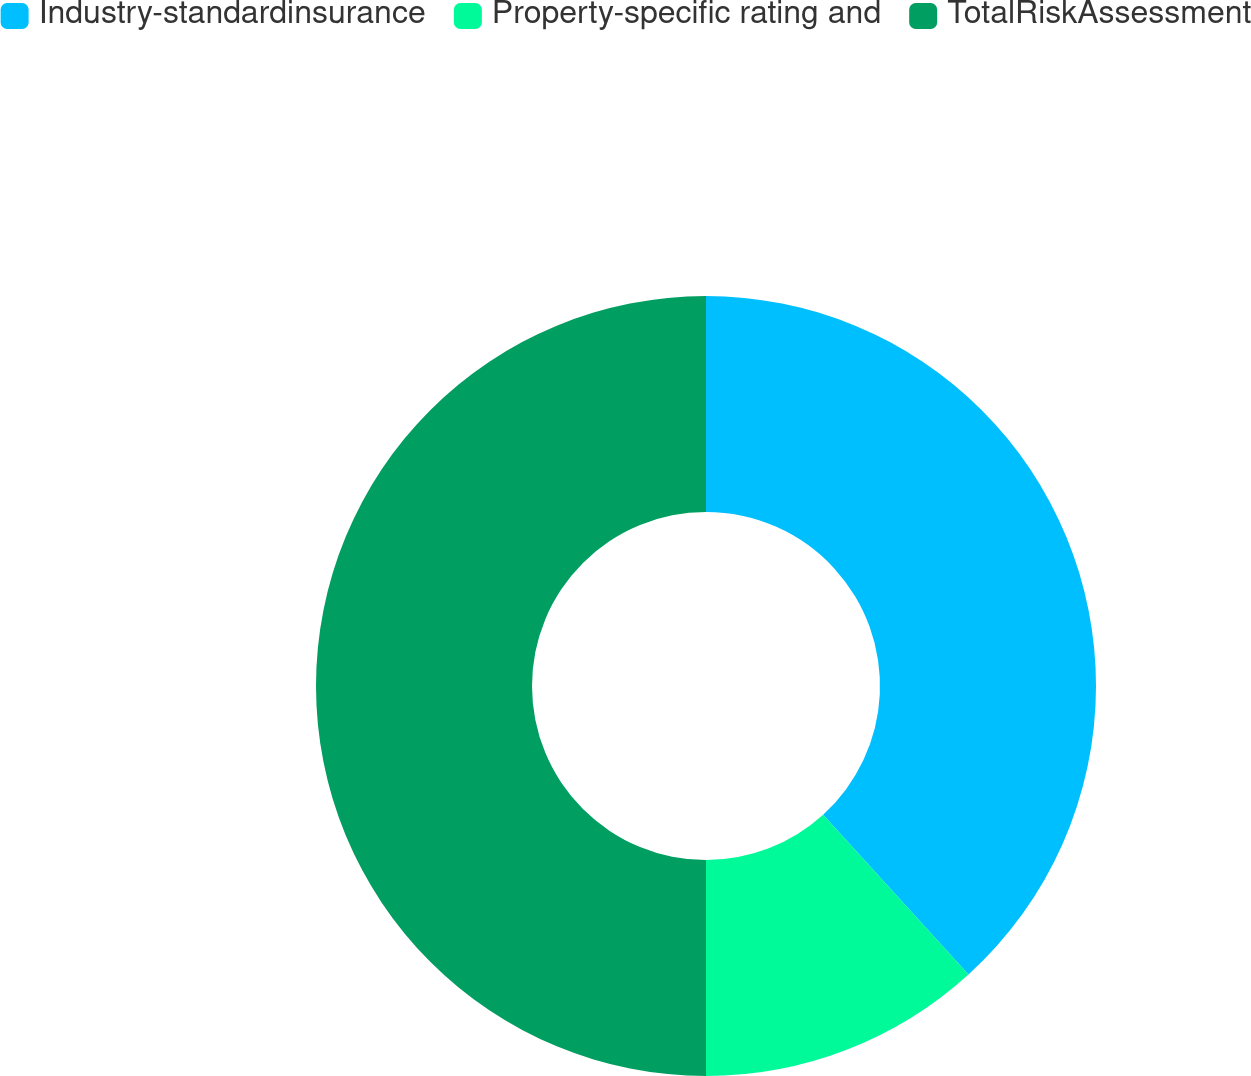<chart> <loc_0><loc_0><loc_500><loc_500><pie_chart><fcel>Industry-standardinsurance<fcel>Property-specific rating and<fcel>TotalRiskAssessment<nl><fcel>38.25%<fcel>11.75%<fcel>50.0%<nl></chart> 